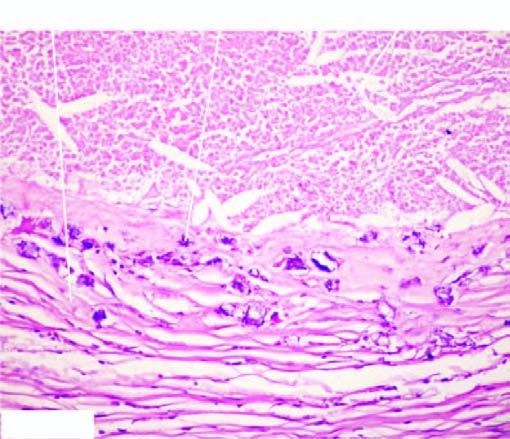what shows healed granulomas?
Answer the question using a single word or phrase. The periphery 